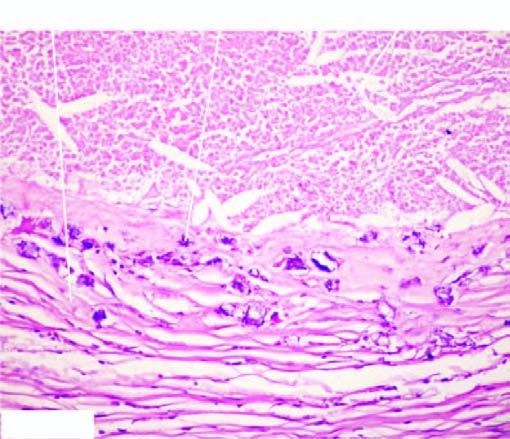what shows healed granulomas?
Answer the question using a single word or phrase. The periphery 